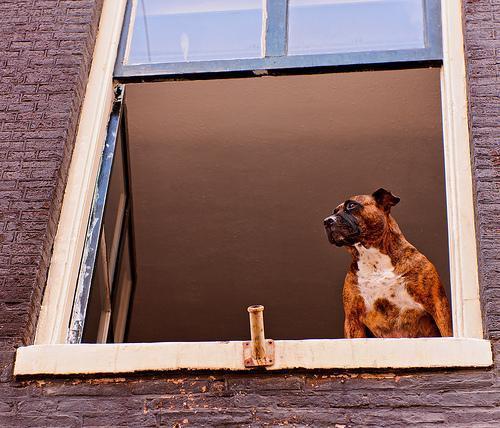How many dogs are pictured?
Give a very brief answer. 1. 